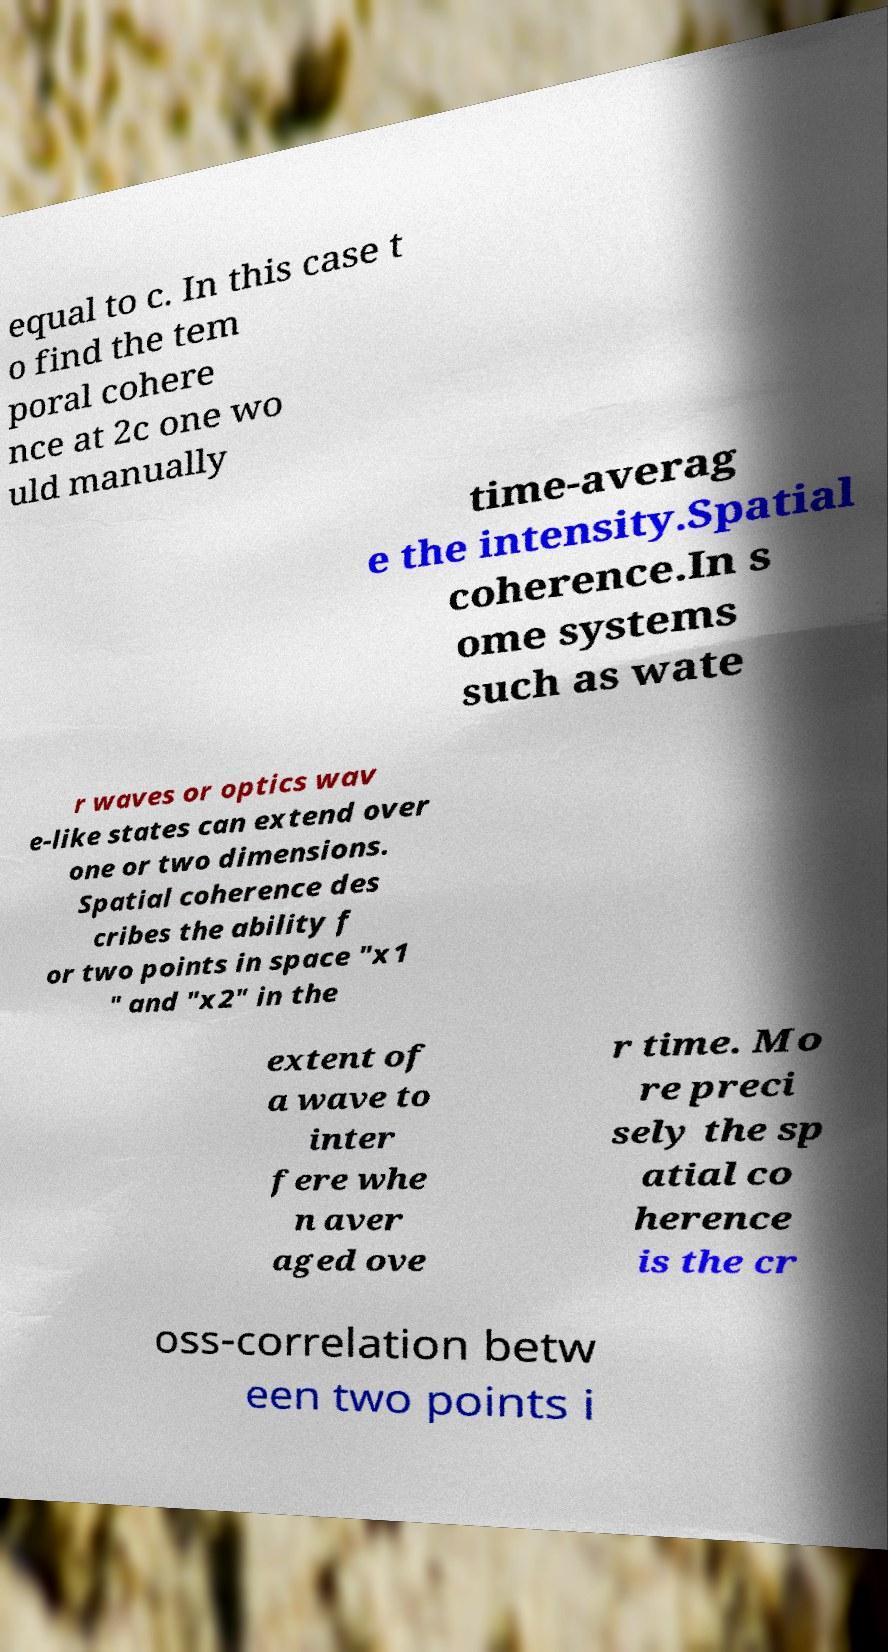For documentation purposes, I need the text within this image transcribed. Could you provide that? equal to c. In this case t o find the tem poral cohere nce at 2c one wo uld manually time-averag e the intensity.Spatial coherence.In s ome systems such as wate r waves or optics wav e-like states can extend over one or two dimensions. Spatial coherence des cribes the ability f or two points in space "x1 " and "x2" in the extent of a wave to inter fere whe n aver aged ove r time. Mo re preci sely the sp atial co herence is the cr oss-correlation betw een two points i 